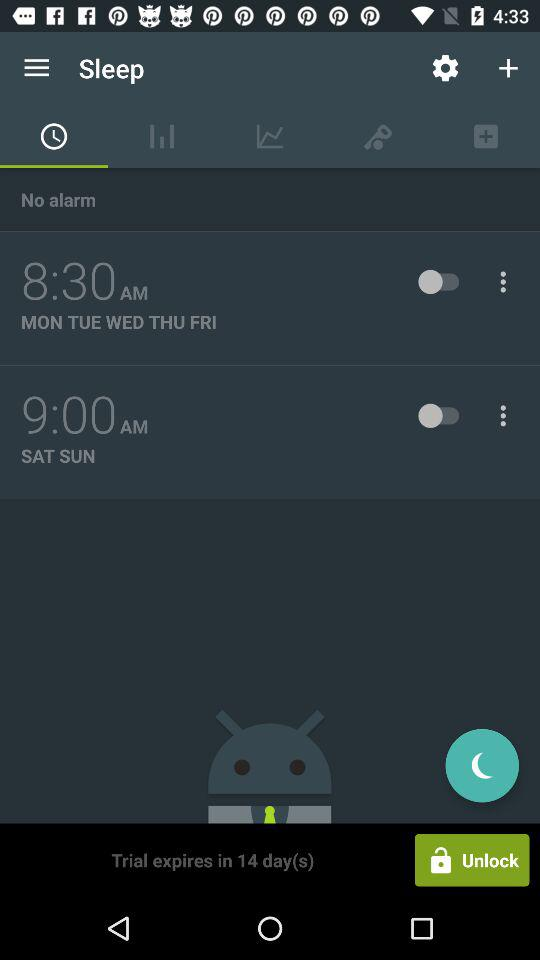How many days are left on the trial?
Answer the question using a single word or phrase. 14 